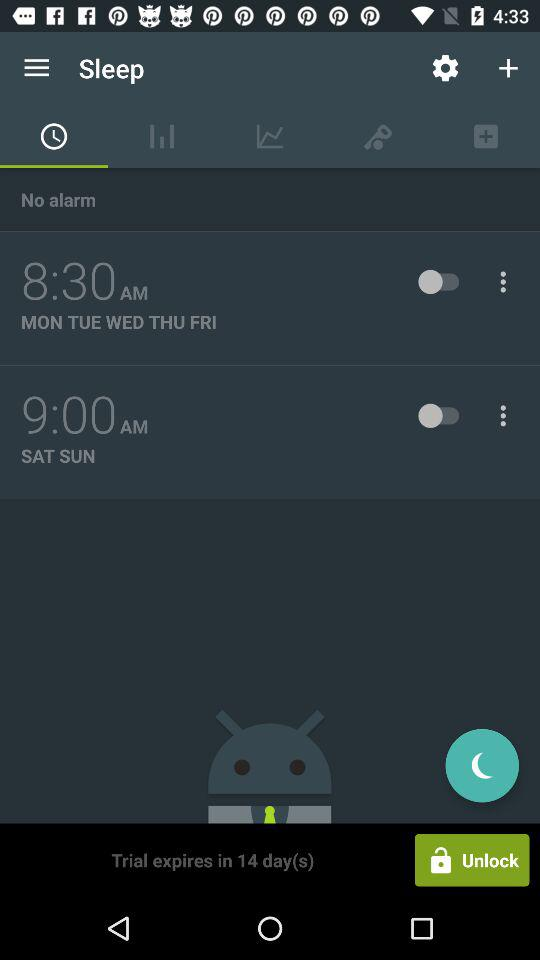How many days are left on the trial?
Answer the question using a single word or phrase. 14 